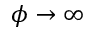<formula> <loc_0><loc_0><loc_500><loc_500>\phi \rightarrow \infty</formula> 